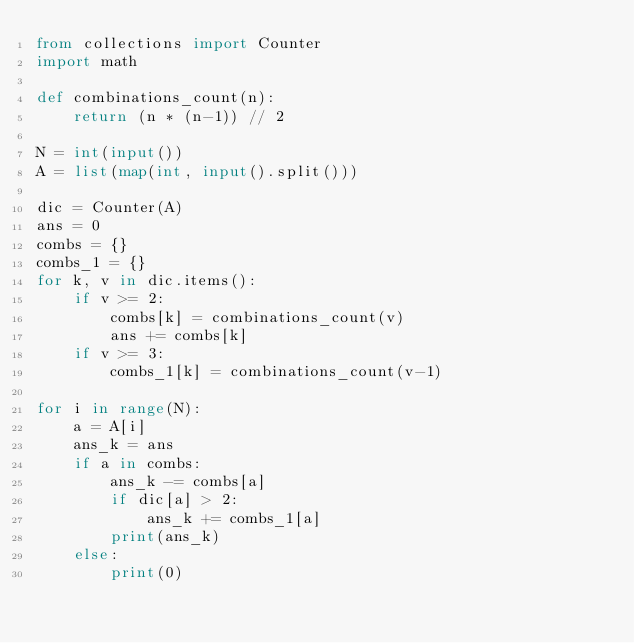<code> <loc_0><loc_0><loc_500><loc_500><_Python_>from collections import Counter
import math

def combinations_count(n):
    return (n * (n-1)) // 2

N = int(input())
A = list(map(int, input().split()))

dic = Counter(A)
ans = 0
combs = {}
combs_1 = {}
for k, v in dic.items():
    if v >= 2:
        combs[k] = combinations_count(v)
        ans += combs[k]
    if v >= 3:
        combs_1[k] = combinations_count(v-1)

for i in range(N):
    a = A[i]
    ans_k = ans
    if a in combs:
        ans_k -= combs[a]
        if dic[a] > 2:
            ans_k += combs_1[a]
        print(ans_k)
    else:
        print(0)

</code> 